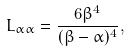<formula> <loc_0><loc_0><loc_500><loc_500>L _ { \alpha \alpha } = \frac { 6 \beta ^ { 4 } } { ( \beta - \alpha ) ^ { 4 } } ,</formula> 